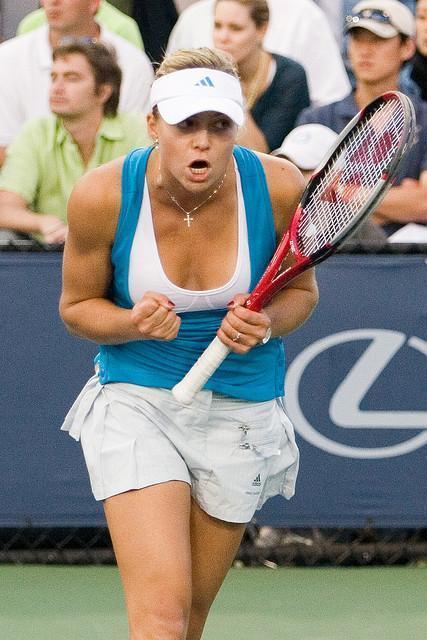How many people are in the picture?
Give a very brief answer. 6. 